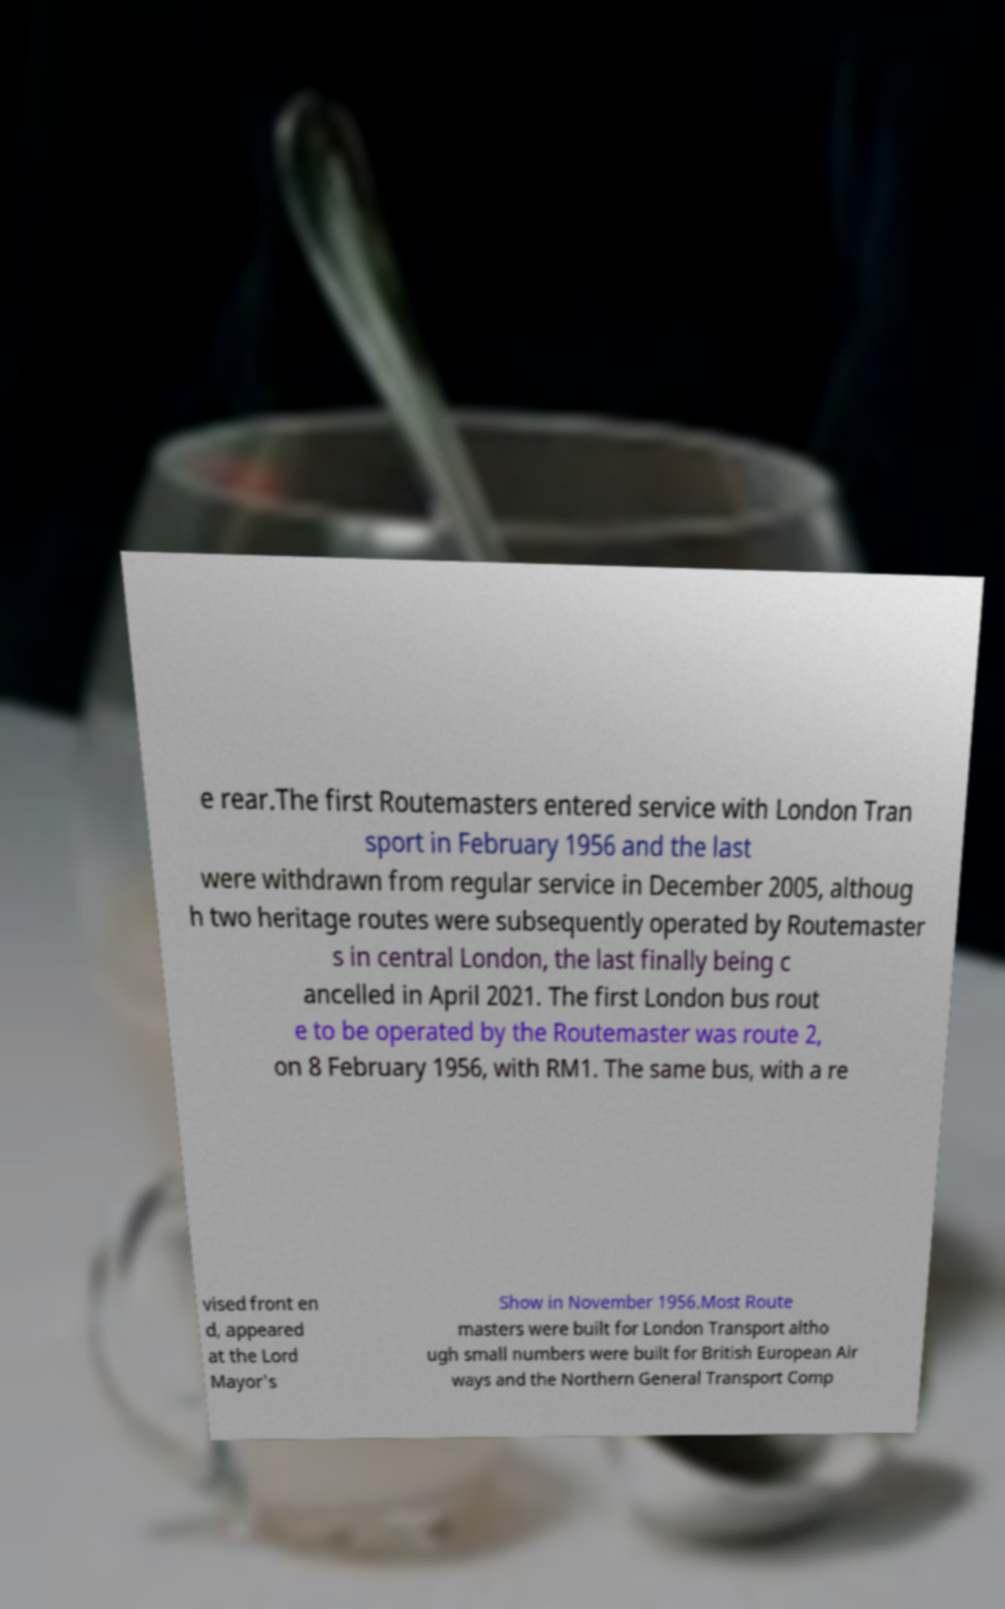Please identify and transcribe the text found in this image. e rear.The first Routemasters entered service with London Tran sport in February 1956 and the last were withdrawn from regular service in December 2005, althoug h two heritage routes were subsequently operated by Routemaster s in central London, the last finally being c ancelled in April 2021. The first London bus rout e to be operated by the Routemaster was route 2, on 8 February 1956, with RM1. The same bus, with a re vised front en d, appeared at the Lord Mayor's Show in November 1956.Most Route masters were built for London Transport altho ugh small numbers were built for British European Air ways and the Northern General Transport Comp 